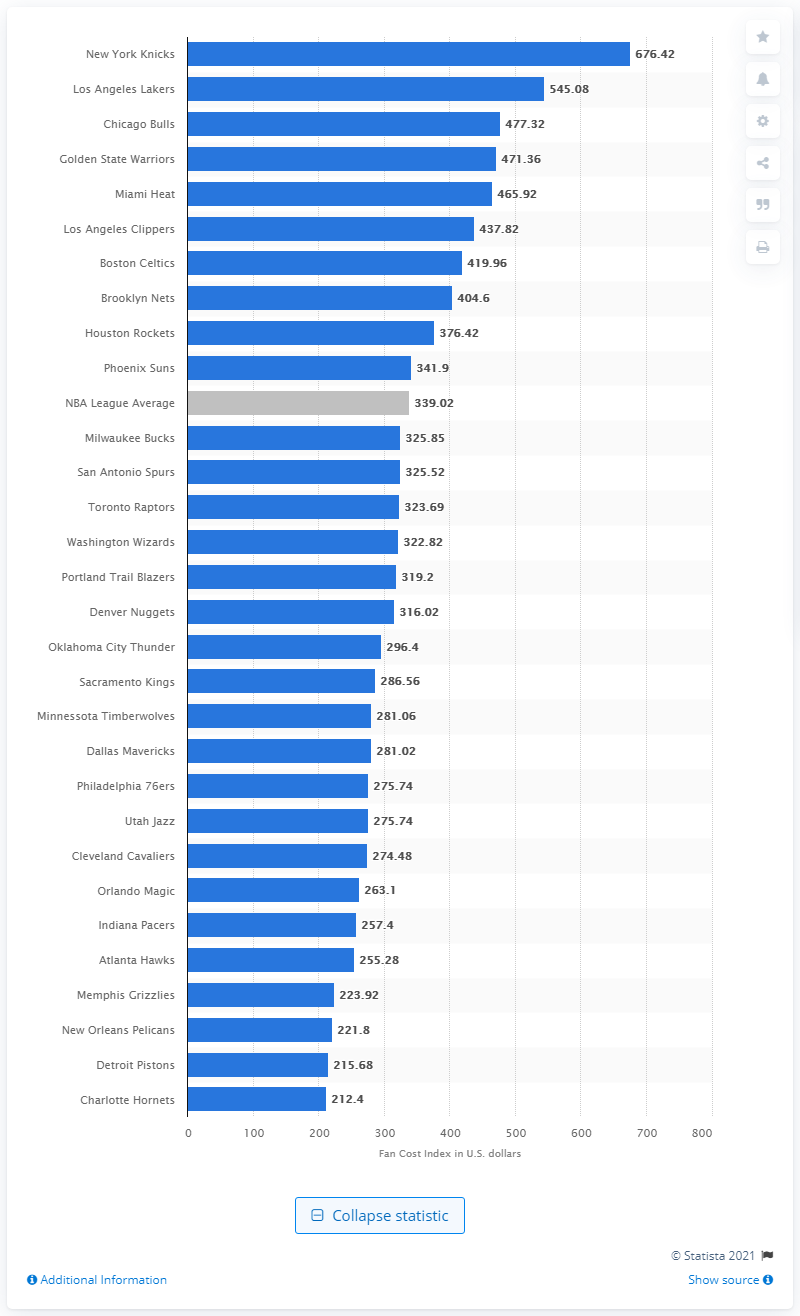Indicate a few pertinent items in this graphic. The average cost of attending a National Basketball Association (NBA) game is approximately 339.02 U.S. dollars. The Fan Cost Index of the Boston Celtics in 2015 was 419.96. 